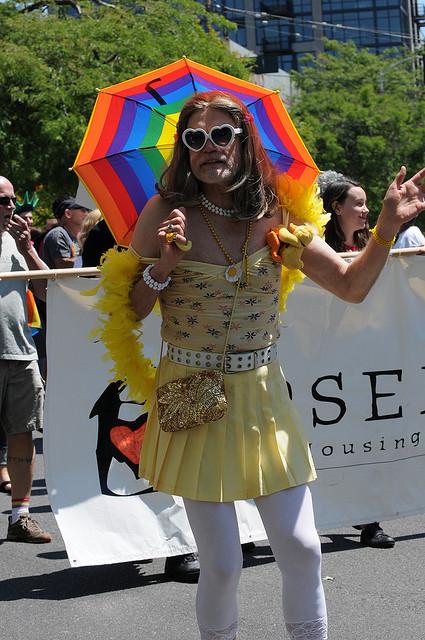Is the parasol open?
Answer briefly. Yes. Is this a man or a woman?
Quick response, please. Man. What is the primary color of the dress?
Keep it brief. Yellow. 